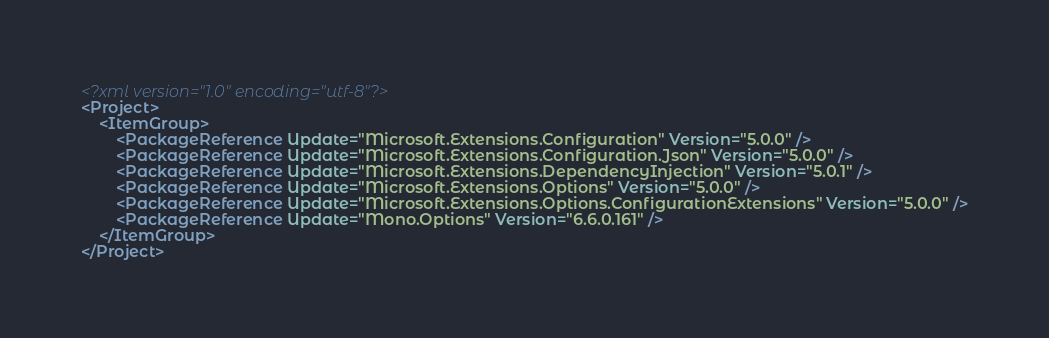<code> <loc_0><loc_0><loc_500><loc_500><_XML_><?xml version="1.0" encoding="utf-8"?>
<Project>
    <ItemGroup>
        <PackageReference Update="Microsoft.Extensions.Configuration" Version="5.0.0" />
        <PackageReference Update="Microsoft.Extensions.Configuration.Json" Version="5.0.0" />
        <PackageReference Update="Microsoft.Extensions.DependencyInjection" Version="5.0.1" />
        <PackageReference Update="Microsoft.Extensions.Options" Version="5.0.0" />
        <PackageReference Update="Microsoft.Extensions.Options.ConfigurationExtensions" Version="5.0.0" />
        <PackageReference Update="Mono.Options" Version="6.6.0.161" />
    </ItemGroup>
</Project></code> 